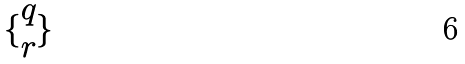<formula> <loc_0><loc_0><loc_500><loc_500>\{ \begin{matrix} q \\ r \end{matrix} \}</formula> 